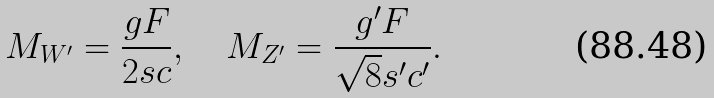Convert formula to latex. <formula><loc_0><loc_0><loc_500><loc_500>M _ { W ^ { \prime } } = \frac { g F } { 2 s c } , \quad M _ { Z ^ { \prime } } = \frac { g ^ { \prime } F } { \sqrt { 8 } s ^ { \prime } c ^ { \prime } } .</formula> 